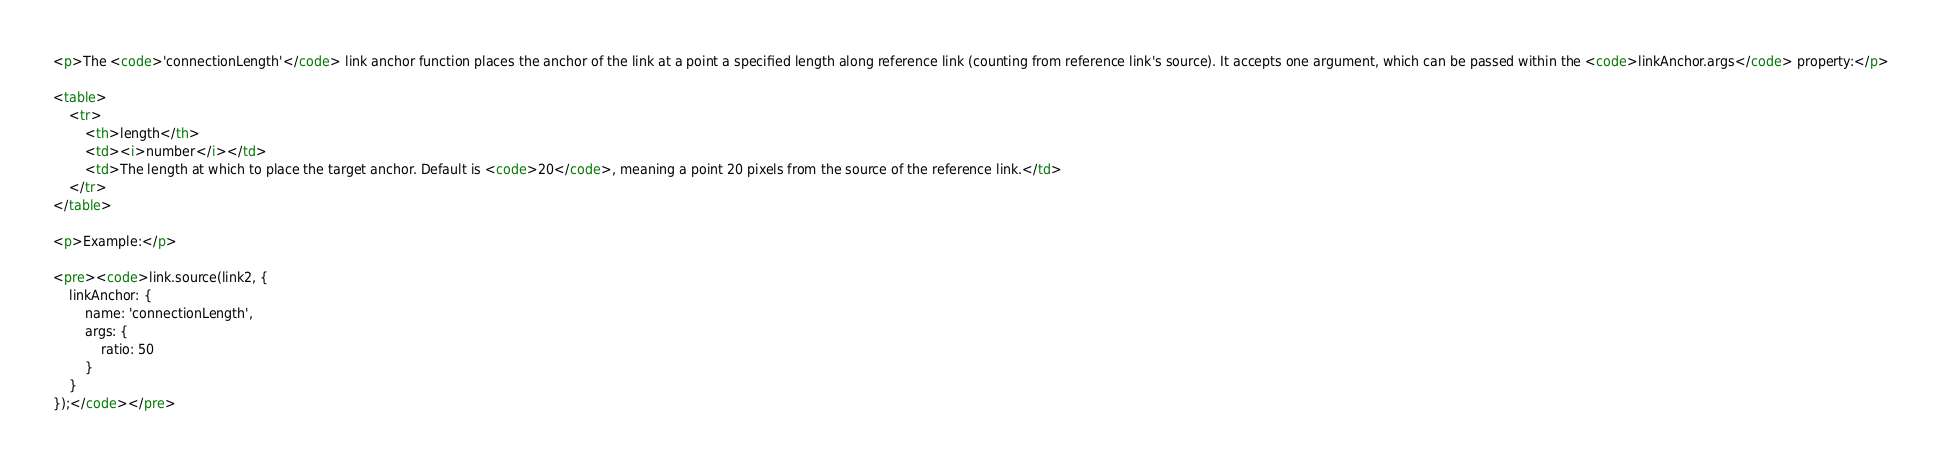Convert code to text. <code><loc_0><loc_0><loc_500><loc_500><_HTML_><p>The <code>'connectionLength'</code> link anchor function places the anchor of the link at a point a specified length along reference link (counting from reference link's source). It accepts one argument, which can be passed within the <code>linkAnchor.args</code> property:</p>

<table>
    <tr>
        <th>length</th>
        <td><i>number</i></td>
        <td>The length at which to place the target anchor. Default is <code>20</code>, meaning a point 20 pixels from the source of the reference link.</td>
    </tr>
</table>

<p>Example:</p>

<pre><code>link.source(link2, {
    linkAnchor: {
        name: 'connectionLength',
        args: {
            ratio: 50
        }
    }
});</code></pre>
</code> 